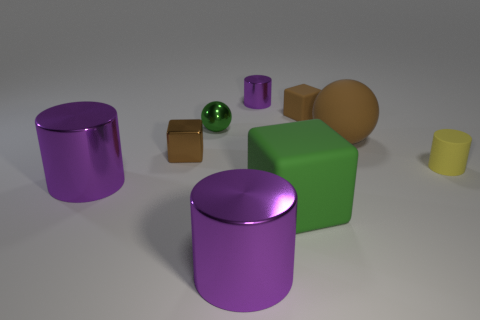Subtract all blue blocks. How many purple cylinders are left? 3 Subtract all cubes. How many objects are left? 6 Add 1 cyan cubes. How many cyan cubes exist? 1 Subtract 0 green cylinders. How many objects are left? 9 Subtract all brown metallic balls. Subtract all yellow matte things. How many objects are left? 8 Add 8 tiny brown matte blocks. How many tiny brown matte blocks are left? 9 